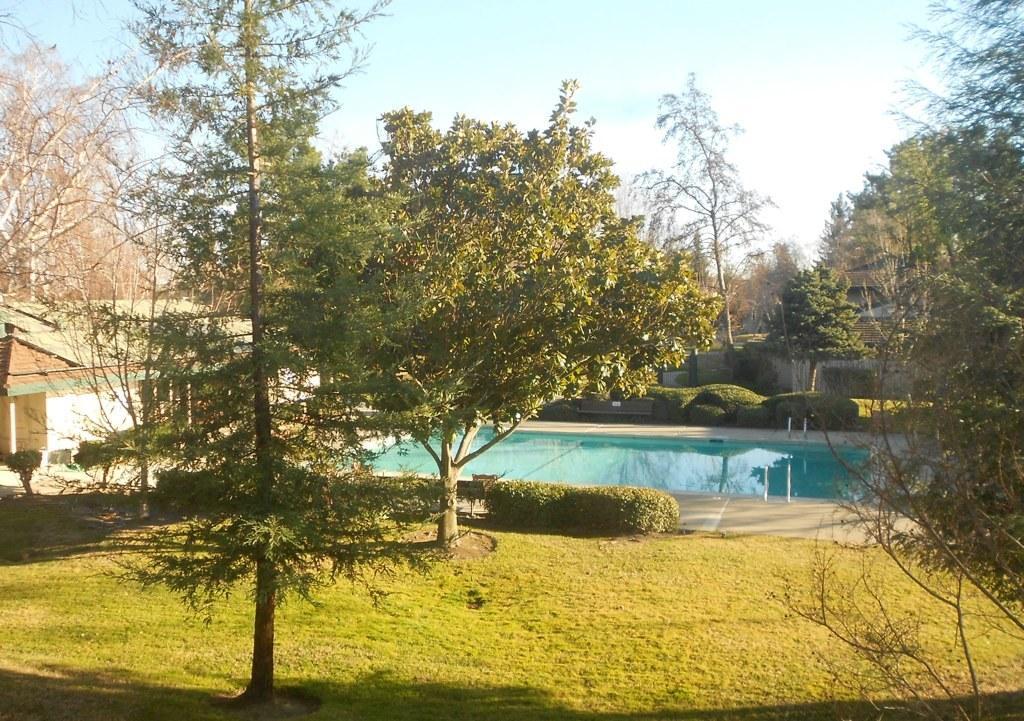Describe this image in one or two sentences. At the bottom of this image, there are trees, plants and grass on the ground. In the background, there is a swimming pool, there are trees, buildings, plants and there are clouds in the sky. 